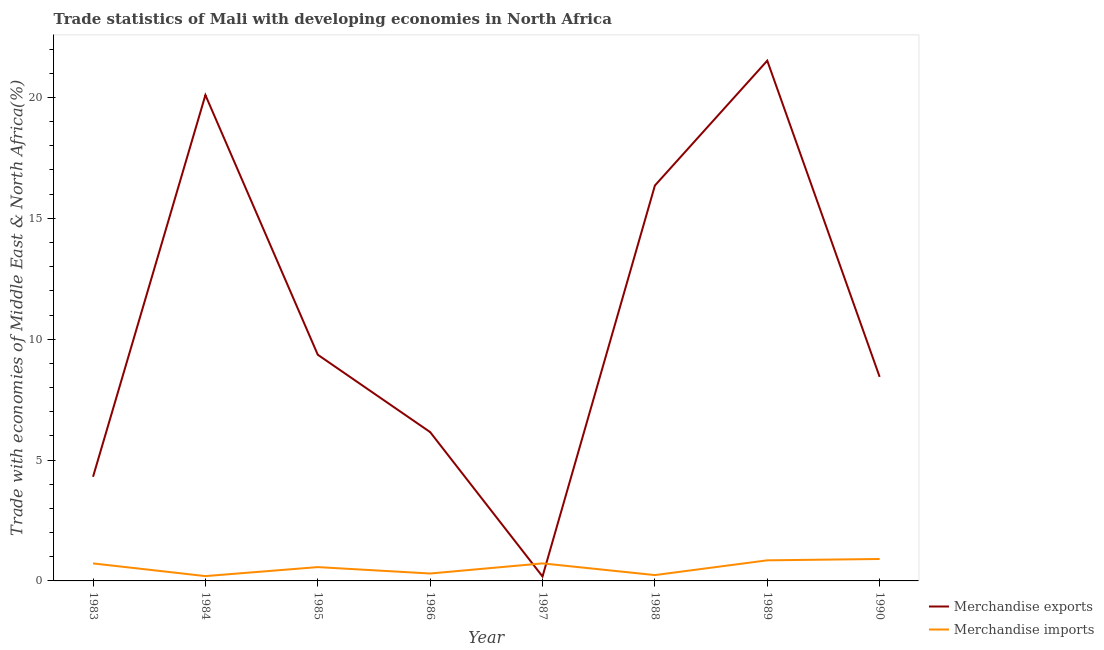What is the merchandise imports in 1983?
Ensure brevity in your answer.  0.72. Across all years, what is the maximum merchandise exports?
Provide a succinct answer. 21.52. Across all years, what is the minimum merchandise imports?
Make the answer very short. 0.2. In which year was the merchandise exports maximum?
Your answer should be compact. 1989. What is the total merchandise imports in the graph?
Make the answer very short. 4.53. What is the difference between the merchandise imports in 1985 and that in 1989?
Keep it short and to the point. -0.28. What is the difference between the merchandise imports in 1985 and the merchandise exports in 1983?
Keep it short and to the point. -3.74. What is the average merchandise imports per year?
Provide a short and direct response. 0.57. In the year 1985, what is the difference between the merchandise imports and merchandise exports?
Provide a short and direct response. -8.79. In how many years, is the merchandise imports greater than 4 %?
Your answer should be compact. 0. What is the ratio of the merchandise imports in 1987 to that in 1990?
Provide a short and direct response. 0.8. Is the difference between the merchandise imports in 1985 and 1986 greater than the difference between the merchandise exports in 1985 and 1986?
Offer a terse response. No. What is the difference between the highest and the second highest merchandise exports?
Your response must be concise. 1.42. What is the difference between the highest and the lowest merchandise imports?
Ensure brevity in your answer.  0.71. Is the sum of the merchandise exports in 1983 and 1988 greater than the maximum merchandise imports across all years?
Your response must be concise. Yes. Does the merchandise imports monotonically increase over the years?
Provide a succinct answer. No. Is the merchandise imports strictly less than the merchandise exports over the years?
Make the answer very short. No. Are the values on the major ticks of Y-axis written in scientific E-notation?
Your response must be concise. No. Does the graph contain any zero values?
Offer a very short reply. No. Where does the legend appear in the graph?
Offer a very short reply. Bottom right. What is the title of the graph?
Give a very brief answer. Trade statistics of Mali with developing economies in North Africa. Does "By country of origin" appear as one of the legend labels in the graph?
Offer a very short reply. No. What is the label or title of the X-axis?
Provide a short and direct response. Year. What is the label or title of the Y-axis?
Offer a very short reply. Trade with economies of Middle East & North Africa(%). What is the Trade with economies of Middle East & North Africa(%) of Merchandise exports in 1983?
Provide a succinct answer. 4.31. What is the Trade with economies of Middle East & North Africa(%) of Merchandise imports in 1983?
Offer a terse response. 0.72. What is the Trade with economies of Middle East & North Africa(%) of Merchandise exports in 1984?
Ensure brevity in your answer.  20.1. What is the Trade with economies of Middle East & North Africa(%) of Merchandise imports in 1984?
Offer a very short reply. 0.2. What is the Trade with economies of Middle East & North Africa(%) in Merchandise exports in 1985?
Ensure brevity in your answer.  9.36. What is the Trade with economies of Middle East & North Africa(%) in Merchandise imports in 1985?
Ensure brevity in your answer.  0.57. What is the Trade with economies of Middle East & North Africa(%) of Merchandise exports in 1986?
Offer a terse response. 6.16. What is the Trade with economies of Middle East & North Africa(%) in Merchandise imports in 1986?
Make the answer very short. 0.31. What is the Trade with economies of Middle East & North Africa(%) in Merchandise exports in 1987?
Offer a terse response. 0.18. What is the Trade with economies of Middle East & North Africa(%) in Merchandise imports in 1987?
Give a very brief answer. 0.73. What is the Trade with economies of Middle East & North Africa(%) of Merchandise exports in 1988?
Your response must be concise. 16.36. What is the Trade with economies of Middle East & North Africa(%) in Merchandise imports in 1988?
Keep it short and to the point. 0.24. What is the Trade with economies of Middle East & North Africa(%) of Merchandise exports in 1989?
Provide a short and direct response. 21.52. What is the Trade with economies of Middle East & North Africa(%) in Merchandise imports in 1989?
Ensure brevity in your answer.  0.85. What is the Trade with economies of Middle East & North Africa(%) of Merchandise exports in 1990?
Your answer should be compact. 8.44. What is the Trade with economies of Middle East & North Africa(%) in Merchandise imports in 1990?
Provide a succinct answer. 0.91. Across all years, what is the maximum Trade with economies of Middle East & North Africa(%) of Merchandise exports?
Offer a terse response. 21.52. Across all years, what is the maximum Trade with economies of Middle East & North Africa(%) in Merchandise imports?
Offer a terse response. 0.91. Across all years, what is the minimum Trade with economies of Middle East & North Africa(%) of Merchandise exports?
Provide a succinct answer. 0.18. Across all years, what is the minimum Trade with economies of Middle East & North Africa(%) in Merchandise imports?
Make the answer very short. 0.2. What is the total Trade with economies of Middle East & North Africa(%) in Merchandise exports in the graph?
Your answer should be compact. 86.43. What is the total Trade with economies of Middle East & North Africa(%) of Merchandise imports in the graph?
Provide a short and direct response. 4.53. What is the difference between the Trade with economies of Middle East & North Africa(%) in Merchandise exports in 1983 and that in 1984?
Your answer should be very brief. -15.79. What is the difference between the Trade with economies of Middle East & North Africa(%) of Merchandise imports in 1983 and that in 1984?
Provide a succinct answer. 0.52. What is the difference between the Trade with economies of Middle East & North Africa(%) in Merchandise exports in 1983 and that in 1985?
Offer a very short reply. -5.05. What is the difference between the Trade with economies of Middle East & North Africa(%) in Merchandise imports in 1983 and that in 1985?
Provide a succinct answer. 0.15. What is the difference between the Trade with economies of Middle East & North Africa(%) of Merchandise exports in 1983 and that in 1986?
Offer a terse response. -1.85. What is the difference between the Trade with economies of Middle East & North Africa(%) in Merchandise imports in 1983 and that in 1986?
Keep it short and to the point. 0.42. What is the difference between the Trade with economies of Middle East & North Africa(%) of Merchandise exports in 1983 and that in 1987?
Your response must be concise. 4.12. What is the difference between the Trade with economies of Middle East & North Africa(%) of Merchandise imports in 1983 and that in 1987?
Provide a succinct answer. -0. What is the difference between the Trade with economies of Middle East & North Africa(%) of Merchandise exports in 1983 and that in 1988?
Your response must be concise. -12.05. What is the difference between the Trade with economies of Middle East & North Africa(%) in Merchandise imports in 1983 and that in 1988?
Your response must be concise. 0.48. What is the difference between the Trade with economies of Middle East & North Africa(%) in Merchandise exports in 1983 and that in 1989?
Provide a succinct answer. -17.21. What is the difference between the Trade with economies of Middle East & North Africa(%) in Merchandise imports in 1983 and that in 1989?
Give a very brief answer. -0.13. What is the difference between the Trade with economies of Middle East & North Africa(%) in Merchandise exports in 1983 and that in 1990?
Offer a very short reply. -4.13. What is the difference between the Trade with economies of Middle East & North Africa(%) in Merchandise imports in 1983 and that in 1990?
Your answer should be compact. -0.18. What is the difference between the Trade with economies of Middle East & North Africa(%) in Merchandise exports in 1984 and that in 1985?
Your response must be concise. 10.74. What is the difference between the Trade with economies of Middle East & North Africa(%) in Merchandise imports in 1984 and that in 1985?
Offer a terse response. -0.37. What is the difference between the Trade with economies of Middle East & North Africa(%) in Merchandise exports in 1984 and that in 1986?
Your answer should be compact. 13.94. What is the difference between the Trade with economies of Middle East & North Africa(%) in Merchandise imports in 1984 and that in 1986?
Offer a terse response. -0.11. What is the difference between the Trade with economies of Middle East & North Africa(%) in Merchandise exports in 1984 and that in 1987?
Your response must be concise. 19.92. What is the difference between the Trade with economies of Middle East & North Africa(%) of Merchandise imports in 1984 and that in 1987?
Offer a very short reply. -0.53. What is the difference between the Trade with economies of Middle East & North Africa(%) of Merchandise exports in 1984 and that in 1988?
Your answer should be compact. 3.74. What is the difference between the Trade with economies of Middle East & North Africa(%) in Merchandise imports in 1984 and that in 1988?
Your answer should be very brief. -0.04. What is the difference between the Trade with economies of Middle East & North Africa(%) in Merchandise exports in 1984 and that in 1989?
Offer a very short reply. -1.42. What is the difference between the Trade with economies of Middle East & North Africa(%) of Merchandise imports in 1984 and that in 1989?
Provide a short and direct response. -0.65. What is the difference between the Trade with economies of Middle East & North Africa(%) in Merchandise exports in 1984 and that in 1990?
Provide a succinct answer. 11.66. What is the difference between the Trade with economies of Middle East & North Africa(%) in Merchandise imports in 1984 and that in 1990?
Your answer should be compact. -0.71. What is the difference between the Trade with economies of Middle East & North Africa(%) of Merchandise exports in 1985 and that in 1986?
Your response must be concise. 3.2. What is the difference between the Trade with economies of Middle East & North Africa(%) of Merchandise imports in 1985 and that in 1986?
Provide a short and direct response. 0.27. What is the difference between the Trade with economies of Middle East & North Africa(%) of Merchandise exports in 1985 and that in 1987?
Provide a succinct answer. 9.17. What is the difference between the Trade with economies of Middle East & North Africa(%) of Merchandise imports in 1985 and that in 1987?
Make the answer very short. -0.15. What is the difference between the Trade with economies of Middle East & North Africa(%) in Merchandise exports in 1985 and that in 1988?
Your answer should be very brief. -7. What is the difference between the Trade with economies of Middle East & North Africa(%) in Merchandise imports in 1985 and that in 1988?
Make the answer very short. 0.33. What is the difference between the Trade with economies of Middle East & North Africa(%) in Merchandise exports in 1985 and that in 1989?
Provide a short and direct response. -12.17. What is the difference between the Trade with economies of Middle East & North Africa(%) in Merchandise imports in 1985 and that in 1989?
Keep it short and to the point. -0.28. What is the difference between the Trade with economies of Middle East & North Africa(%) of Merchandise exports in 1985 and that in 1990?
Provide a short and direct response. 0.92. What is the difference between the Trade with economies of Middle East & North Africa(%) of Merchandise imports in 1985 and that in 1990?
Offer a very short reply. -0.34. What is the difference between the Trade with economies of Middle East & North Africa(%) of Merchandise exports in 1986 and that in 1987?
Your answer should be compact. 5.97. What is the difference between the Trade with economies of Middle East & North Africa(%) of Merchandise imports in 1986 and that in 1987?
Your answer should be very brief. -0.42. What is the difference between the Trade with economies of Middle East & North Africa(%) of Merchandise exports in 1986 and that in 1988?
Provide a succinct answer. -10.2. What is the difference between the Trade with economies of Middle East & North Africa(%) of Merchandise imports in 1986 and that in 1988?
Your answer should be compact. 0.06. What is the difference between the Trade with economies of Middle East & North Africa(%) of Merchandise exports in 1986 and that in 1989?
Offer a terse response. -15.37. What is the difference between the Trade with economies of Middle East & North Africa(%) of Merchandise imports in 1986 and that in 1989?
Your response must be concise. -0.55. What is the difference between the Trade with economies of Middle East & North Africa(%) of Merchandise exports in 1986 and that in 1990?
Keep it short and to the point. -2.28. What is the difference between the Trade with economies of Middle East & North Africa(%) in Merchandise imports in 1986 and that in 1990?
Keep it short and to the point. -0.6. What is the difference between the Trade with economies of Middle East & North Africa(%) of Merchandise exports in 1987 and that in 1988?
Keep it short and to the point. -16.17. What is the difference between the Trade with economies of Middle East & North Africa(%) of Merchandise imports in 1987 and that in 1988?
Your answer should be compact. 0.48. What is the difference between the Trade with economies of Middle East & North Africa(%) of Merchandise exports in 1987 and that in 1989?
Provide a succinct answer. -21.34. What is the difference between the Trade with economies of Middle East & North Africa(%) in Merchandise imports in 1987 and that in 1989?
Provide a succinct answer. -0.13. What is the difference between the Trade with economies of Middle East & North Africa(%) of Merchandise exports in 1987 and that in 1990?
Your response must be concise. -8.26. What is the difference between the Trade with economies of Middle East & North Africa(%) in Merchandise imports in 1987 and that in 1990?
Offer a very short reply. -0.18. What is the difference between the Trade with economies of Middle East & North Africa(%) of Merchandise exports in 1988 and that in 1989?
Offer a very short reply. -5.17. What is the difference between the Trade with economies of Middle East & North Africa(%) of Merchandise imports in 1988 and that in 1989?
Keep it short and to the point. -0.61. What is the difference between the Trade with economies of Middle East & North Africa(%) in Merchandise exports in 1988 and that in 1990?
Your answer should be very brief. 7.92. What is the difference between the Trade with economies of Middle East & North Africa(%) in Merchandise imports in 1988 and that in 1990?
Make the answer very short. -0.67. What is the difference between the Trade with economies of Middle East & North Africa(%) in Merchandise exports in 1989 and that in 1990?
Ensure brevity in your answer.  13.08. What is the difference between the Trade with economies of Middle East & North Africa(%) of Merchandise imports in 1989 and that in 1990?
Your answer should be very brief. -0.06. What is the difference between the Trade with economies of Middle East & North Africa(%) of Merchandise exports in 1983 and the Trade with economies of Middle East & North Africa(%) of Merchandise imports in 1984?
Provide a short and direct response. 4.11. What is the difference between the Trade with economies of Middle East & North Africa(%) of Merchandise exports in 1983 and the Trade with economies of Middle East & North Africa(%) of Merchandise imports in 1985?
Offer a terse response. 3.74. What is the difference between the Trade with economies of Middle East & North Africa(%) in Merchandise exports in 1983 and the Trade with economies of Middle East & North Africa(%) in Merchandise imports in 1986?
Your response must be concise. 4. What is the difference between the Trade with economies of Middle East & North Africa(%) of Merchandise exports in 1983 and the Trade with economies of Middle East & North Africa(%) of Merchandise imports in 1987?
Provide a succinct answer. 3.58. What is the difference between the Trade with economies of Middle East & North Africa(%) in Merchandise exports in 1983 and the Trade with economies of Middle East & North Africa(%) in Merchandise imports in 1988?
Provide a succinct answer. 4.07. What is the difference between the Trade with economies of Middle East & North Africa(%) in Merchandise exports in 1983 and the Trade with economies of Middle East & North Africa(%) in Merchandise imports in 1989?
Make the answer very short. 3.46. What is the difference between the Trade with economies of Middle East & North Africa(%) in Merchandise exports in 1983 and the Trade with economies of Middle East & North Africa(%) in Merchandise imports in 1990?
Your answer should be very brief. 3.4. What is the difference between the Trade with economies of Middle East & North Africa(%) of Merchandise exports in 1984 and the Trade with economies of Middle East & North Africa(%) of Merchandise imports in 1985?
Provide a succinct answer. 19.53. What is the difference between the Trade with economies of Middle East & North Africa(%) of Merchandise exports in 1984 and the Trade with economies of Middle East & North Africa(%) of Merchandise imports in 1986?
Your answer should be compact. 19.79. What is the difference between the Trade with economies of Middle East & North Africa(%) of Merchandise exports in 1984 and the Trade with economies of Middle East & North Africa(%) of Merchandise imports in 1987?
Give a very brief answer. 19.37. What is the difference between the Trade with economies of Middle East & North Africa(%) in Merchandise exports in 1984 and the Trade with economies of Middle East & North Africa(%) in Merchandise imports in 1988?
Give a very brief answer. 19.86. What is the difference between the Trade with economies of Middle East & North Africa(%) in Merchandise exports in 1984 and the Trade with economies of Middle East & North Africa(%) in Merchandise imports in 1989?
Offer a terse response. 19.25. What is the difference between the Trade with economies of Middle East & North Africa(%) in Merchandise exports in 1984 and the Trade with economies of Middle East & North Africa(%) in Merchandise imports in 1990?
Provide a short and direct response. 19.19. What is the difference between the Trade with economies of Middle East & North Africa(%) of Merchandise exports in 1985 and the Trade with economies of Middle East & North Africa(%) of Merchandise imports in 1986?
Provide a short and direct response. 9.05. What is the difference between the Trade with economies of Middle East & North Africa(%) of Merchandise exports in 1985 and the Trade with economies of Middle East & North Africa(%) of Merchandise imports in 1987?
Make the answer very short. 8.63. What is the difference between the Trade with economies of Middle East & North Africa(%) in Merchandise exports in 1985 and the Trade with economies of Middle East & North Africa(%) in Merchandise imports in 1988?
Provide a succinct answer. 9.12. What is the difference between the Trade with economies of Middle East & North Africa(%) of Merchandise exports in 1985 and the Trade with economies of Middle East & North Africa(%) of Merchandise imports in 1989?
Offer a terse response. 8.51. What is the difference between the Trade with economies of Middle East & North Africa(%) of Merchandise exports in 1985 and the Trade with economies of Middle East & North Africa(%) of Merchandise imports in 1990?
Provide a short and direct response. 8.45. What is the difference between the Trade with economies of Middle East & North Africa(%) of Merchandise exports in 1986 and the Trade with economies of Middle East & North Africa(%) of Merchandise imports in 1987?
Give a very brief answer. 5.43. What is the difference between the Trade with economies of Middle East & North Africa(%) of Merchandise exports in 1986 and the Trade with economies of Middle East & North Africa(%) of Merchandise imports in 1988?
Provide a short and direct response. 5.92. What is the difference between the Trade with economies of Middle East & North Africa(%) of Merchandise exports in 1986 and the Trade with economies of Middle East & North Africa(%) of Merchandise imports in 1989?
Offer a terse response. 5.31. What is the difference between the Trade with economies of Middle East & North Africa(%) of Merchandise exports in 1986 and the Trade with economies of Middle East & North Africa(%) of Merchandise imports in 1990?
Keep it short and to the point. 5.25. What is the difference between the Trade with economies of Middle East & North Africa(%) of Merchandise exports in 1987 and the Trade with economies of Middle East & North Africa(%) of Merchandise imports in 1988?
Offer a very short reply. -0.06. What is the difference between the Trade with economies of Middle East & North Africa(%) in Merchandise exports in 1987 and the Trade with economies of Middle East & North Africa(%) in Merchandise imports in 1989?
Your answer should be very brief. -0.67. What is the difference between the Trade with economies of Middle East & North Africa(%) of Merchandise exports in 1987 and the Trade with economies of Middle East & North Africa(%) of Merchandise imports in 1990?
Ensure brevity in your answer.  -0.72. What is the difference between the Trade with economies of Middle East & North Africa(%) in Merchandise exports in 1988 and the Trade with economies of Middle East & North Africa(%) in Merchandise imports in 1989?
Keep it short and to the point. 15.51. What is the difference between the Trade with economies of Middle East & North Africa(%) in Merchandise exports in 1988 and the Trade with economies of Middle East & North Africa(%) in Merchandise imports in 1990?
Ensure brevity in your answer.  15.45. What is the difference between the Trade with economies of Middle East & North Africa(%) of Merchandise exports in 1989 and the Trade with economies of Middle East & North Africa(%) of Merchandise imports in 1990?
Your answer should be compact. 20.61. What is the average Trade with economies of Middle East & North Africa(%) of Merchandise exports per year?
Provide a short and direct response. 10.8. What is the average Trade with economies of Middle East & North Africa(%) of Merchandise imports per year?
Provide a succinct answer. 0.57. In the year 1983, what is the difference between the Trade with economies of Middle East & North Africa(%) in Merchandise exports and Trade with economies of Middle East & North Africa(%) in Merchandise imports?
Provide a short and direct response. 3.58. In the year 1984, what is the difference between the Trade with economies of Middle East & North Africa(%) in Merchandise exports and Trade with economies of Middle East & North Africa(%) in Merchandise imports?
Provide a short and direct response. 19.9. In the year 1985, what is the difference between the Trade with economies of Middle East & North Africa(%) of Merchandise exports and Trade with economies of Middle East & North Africa(%) of Merchandise imports?
Your answer should be very brief. 8.79. In the year 1986, what is the difference between the Trade with economies of Middle East & North Africa(%) of Merchandise exports and Trade with economies of Middle East & North Africa(%) of Merchandise imports?
Offer a very short reply. 5.85. In the year 1987, what is the difference between the Trade with economies of Middle East & North Africa(%) in Merchandise exports and Trade with economies of Middle East & North Africa(%) in Merchandise imports?
Offer a very short reply. -0.54. In the year 1988, what is the difference between the Trade with economies of Middle East & North Africa(%) of Merchandise exports and Trade with economies of Middle East & North Africa(%) of Merchandise imports?
Keep it short and to the point. 16.12. In the year 1989, what is the difference between the Trade with economies of Middle East & North Africa(%) of Merchandise exports and Trade with economies of Middle East & North Africa(%) of Merchandise imports?
Make the answer very short. 20.67. In the year 1990, what is the difference between the Trade with economies of Middle East & North Africa(%) of Merchandise exports and Trade with economies of Middle East & North Africa(%) of Merchandise imports?
Make the answer very short. 7.53. What is the ratio of the Trade with economies of Middle East & North Africa(%) in Merchandise exports in 1983 to that in 1984?
Provide a short and direct response. 0.21. What is the ratio of the Trade with economies of Middle East & North Africa(%) of Merchandise imports in 1983 to that in 1984?
Offer a terse response. 3.63. What is the ratio of the Trade with economies of Middle East & North Africa(%) in Merchandise exports in 1983 to that in 1985?
Make the answer very short. 0.46. What is the ratio of the Trade with economies of Middle East & North Africa(%) of Merchandise imports in 1983 to that in 1985?
Make the answer very short. 1.27. What is the ratio of the Trade with economies of Middle East & North Africa(%) of Merchandise exports in 1983 to that in 1986?
Offer a terse response. 0.7. What is the ratio of the Trade with economies of Middle East & North Africa(%) of Merchandise imports in 1983 to that in 1986?
Your answer should be compact. 2.36. What is the ratio of the Trade with economies of Middle East & North Africa(%) in Merchandise exports in 1983 to that in 1987?
Your answer should be compact. 23.44. What is the ratio of the Trade with economies of Middle East & North Africa(%) in Merchandise imports in 1983 to that in 1987?
Ensure brevity in your answer.  1. What is the ratio of the Trade with economies of Middle East & North Africa(%) in Merchandise exports in 1983 to that in 1988?
Offer a very short reply. 0.26. What is the ratio of the Trade with economies of Middle East & North Africa(%) of Merchandise imports in 1983 to that in 1988?
Your answer should be very brief. 3. What is the ratio of the Trade with economies of Middle East & North Africa(%) of Merchandise exports in 1983 to that in 1989?
Offer a very short reply. 0.2. What is the ratio of the Trade with economies of Middle East & North Africa(%) in Merchandise imports in 1983 to that in 1989?
Your response must be concise. 0.85. What is the ratio of the Trade with economies of Middle East & North Africa(%) of Merchandise exports in 1983 to that in 1990?
Your answer should be compact. 0.51. What is the ratio of the Trade with economies of Middle East & North Africa(%) of Merchandise imports in 1983 to that in 1990?
Provide a succinct answer. 0.8. What is the ratio of the Trade with economies of Middle East & North Africa(%) in Merchandise exports in 1984 to that in 1985?
Your answer should be compact. 2.15. What is the ratio of the Trade with economies of Middle East & North Africa(%) in Merchandise imports in 1984 to that in 1985?
Offer a very short reply. 0.35. What is the ratio of the Trade with economies of Middle East & North Africa(%) of Merchandise exports in 1984 to that in 1986?
Offer a very short reply. 3.26. What is the ratio of the Trade with economies of Middle East & North Africa(%) of Merchandise imports in 1984 to that in 1986?
Your response must be concise. 0.65. What is the ratio of the Trade with economies of Middle East & North Africa(%) in Merchandise exports in 1984 to that in 1987?
Offer a very short reply. 109.33. What is the ratio of the Trade with economies of Middle East & North Africa(%) of Merchandise imports in 1984 to that in 1987?
Keep it short and to the point. 0.28. What is the ratio of the Trade with economies of Middle East & North Africa(%) in Merchandise exports in 1984 to that in 1988?
Keep it short and to the point. 1.23. What is the ratio of the Trade with economies of Middle East & North Africa(%) of Merchandise imports in 1984 to that in 1988?
Your answer should be very brief. 0.83. What is the ratio of the Trade with economies of Middle East & North Africa(%) of Merchandise exports in 1984 to that in 1989?
Your answer should be very brief. 0.93. What is the ratio of the Trade with economies of Middle East & North Africa(%) in Merchandise imports in 1984 to that in 1989?
Provide a short and direct response. 0.23. What is the ratio of the Trade with economies of Middle East & North Africa(%) of Merchandise exports in 1984 to that in 1990?
Provide a short and direct response. 2.38. What is the ratio of the Trade with economies of Middle East & North Africa(%) in Merchandise imports in 1984 to that in 1990?
Provide a short and direct response. 0.22. What is the ratio of the Trade with economies of Middle East & North Africa(%) in Merchandise exports in 1985 to that in 1986?
Your response must be concise. 1.52. What is the ratio of the Trade with economies of Middle East & North Africa(%) of Merchandise imports in 1985 to that in 1986?
Provide a succinct answer. 1.87. What is the ratio of the Trade with economies of Middle East & North Africa(%) in Merchandise exports in 1985 to that in 1987?
Provide a succinct answer. 50.9. What is the ratio of the Trade with economies of Middle East & North Africa(%) in Merchandise imports in 1985 to that in 1987?
Your answer should be very brief. 0.79. What is the ratio of the Trade with economies of Middle East & North Africa(%) of Merchandise exports in 1985 to that in 1988?
Keep it short and to the point. 0.57. What is the ratio of the Trade with economies of Middle East & North Africa(%) in Merchandise imports in 1985 to that in 1988?
Ensure brevity in your answer.  2.37. What is the ratio of the Trade with economies of Middle East & North Africa(%) of Merchandise exports in 1985 to that in 1989?
Provide a short and direct response. 0.43. What is the ratio of the Trade with economies of Middle East & North Africa(%) in Merchandise imports in 1985 to that in 1989?
Give a very brief answer. 0.67. What is the ratio of the Trade with economies of Middle East & North Africa(%) in Merchandise exports in 1985 to that in 1990?
Give a very brief answer. 1.11. What is the ratio of the Trade with economies of Middle East & North Africa(%) in Merchandise imports in 1985 to that in 1990?
Give a very brief answer. 0.63. What is the ratio of the Trade with economies of Middle East & North Africa(%) of Merchandise exports in 1986 to that in 1987?
Provide a succinct answer. 33.49. What is the ratio of the Trade with economies of Middle East & North Africa(%) in Merchandise imports in 1986 to that in 1987?
Provide a succinct answer. 0.42. What is the ratio of the Trade with economies of Middle East & North Africa(%) in Merchandise exports in 1986 to that in 1988?
Offer a terse response. 0.38. What is the ratio of the Trade with economies of Middle East & North Africa(%) of Merchandise imports in 1986 to that in 1988?
Make the answer very short. 1.27. What is the ratio of the Trade with economies of Middle East & North Africa(%) of Merchandise exports in 1986 to that in 1989?
Make the answer very short. 0.29. What is the ratio of the Trade with economies of Middle East & North Africa(%) of Merchandise imports in 1986 to that in 1989?
Your response must be concise. 0.36. What is the ratio of the Trade with economies of Middle East & North Africa(%) of Merchandise exports in 1986 to that in 1990?
Your answer should be very brief. 0.73. What is the ratio of the Trade with economies of Middle East & North Africa(%) of Merchandise imports in 1986 to that in 1990?
Your response must be concise. 0.34. What is the ratio of the Trade with economies of Middle East & North Africa(%) in Merchandise exports in 1987 to that in 1988?
Ensure brevity in your answer.  0.01. What is the ratio of the Trade with economies of Middle East & North Africa(%) of Merchandise imports in 1987 to that in 1988?
Give a very brief answer. 3. What is the ratio of the Trade with economies of Middle East & North Africa(%) of Merchandise exports in 1987 to that in 1989?
Your answer should be compact. 0.01. What is the ratio of the Trade with economies of Middle East & North Africa(%) of Merchandise imports in 1987 to that in 1989?
Provide a short and direct response. 0.85. What is the ratio of the Trade with economies of Middle East & North Africa(%) of Merchandise exports in 1987 to that in 1990?
Keep it short and to the point. 0.02. What is the ratio of the Trade with economies of Middle East & North Africa(%) in Merchandise imports in 1987 to that in 1990?
Your answer should be very brief. 0.8. What is the ratio of the Trade with economies of Middle East & North Africa(%) of Merchandise exports in 1988 to that in 1989?
Provide a succinct answer. 0.76. What is the ratio of the Trade with economies of Middle East & North Africa(%) of Merchandise imports in 1988 to that in 1989?
Give a very brief answer. 0.28. What is the ratio of the Trade with economies of Middle East & North Africa(%) in Merchandise exports in 1988 to that in 1990?
Give a very brief answer. 1.94. What is the ratio of the Trade with economies of Middle East & North Africa(%) of Merchandise imports in 1988 to that in 1990?
Offer a terse response. 0.27. What is the ratio of the Trade with economies of Middle East & North Africa(%) in Merchandise exports in 1989 to that in 1990?
Provide a succinct answer. 2.55. What is the ratio of the Trade with economies of Middle East & North Africa(%) in Merchandise imports in 1989 to that in 1990?
Give a very brief answer. 0.94. What is the difference between the highest and the second highest Trade with economies of Middle East & North Africa(%) of Merchandise exports?
Your answer should be very brief. 1.42. What is the difference between the highest and the second highest Trade with economies of Middle East & North Africa(%) of Merchandise imports?
Ensure brevity in your answer.  0.06. What is the difference between the highest and the lowest Trade with economies of Middle East & North Africa(%) of Merchandise exports?
Your answer should be very brief. 21.34. What is the difference between the highest and the lowest Trade with economies of Middle East & North Africa(%) of Merchandise imports?
Keep it short and to the point. 0.71. 